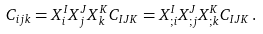Convert formula to latex. <formula><loc_0><loc_0><loc_500><loc_500>C _ { i j k } = X ^ { I } _ { i } X ^ { J } _ { j } X ^ { K } _ { k } C _ { I J K } = X ^ { I } _ { ; i } X ^ { J } _ { ; j } X ^ { K } _ { ; k } C _ { I J K } \, .</formula> 